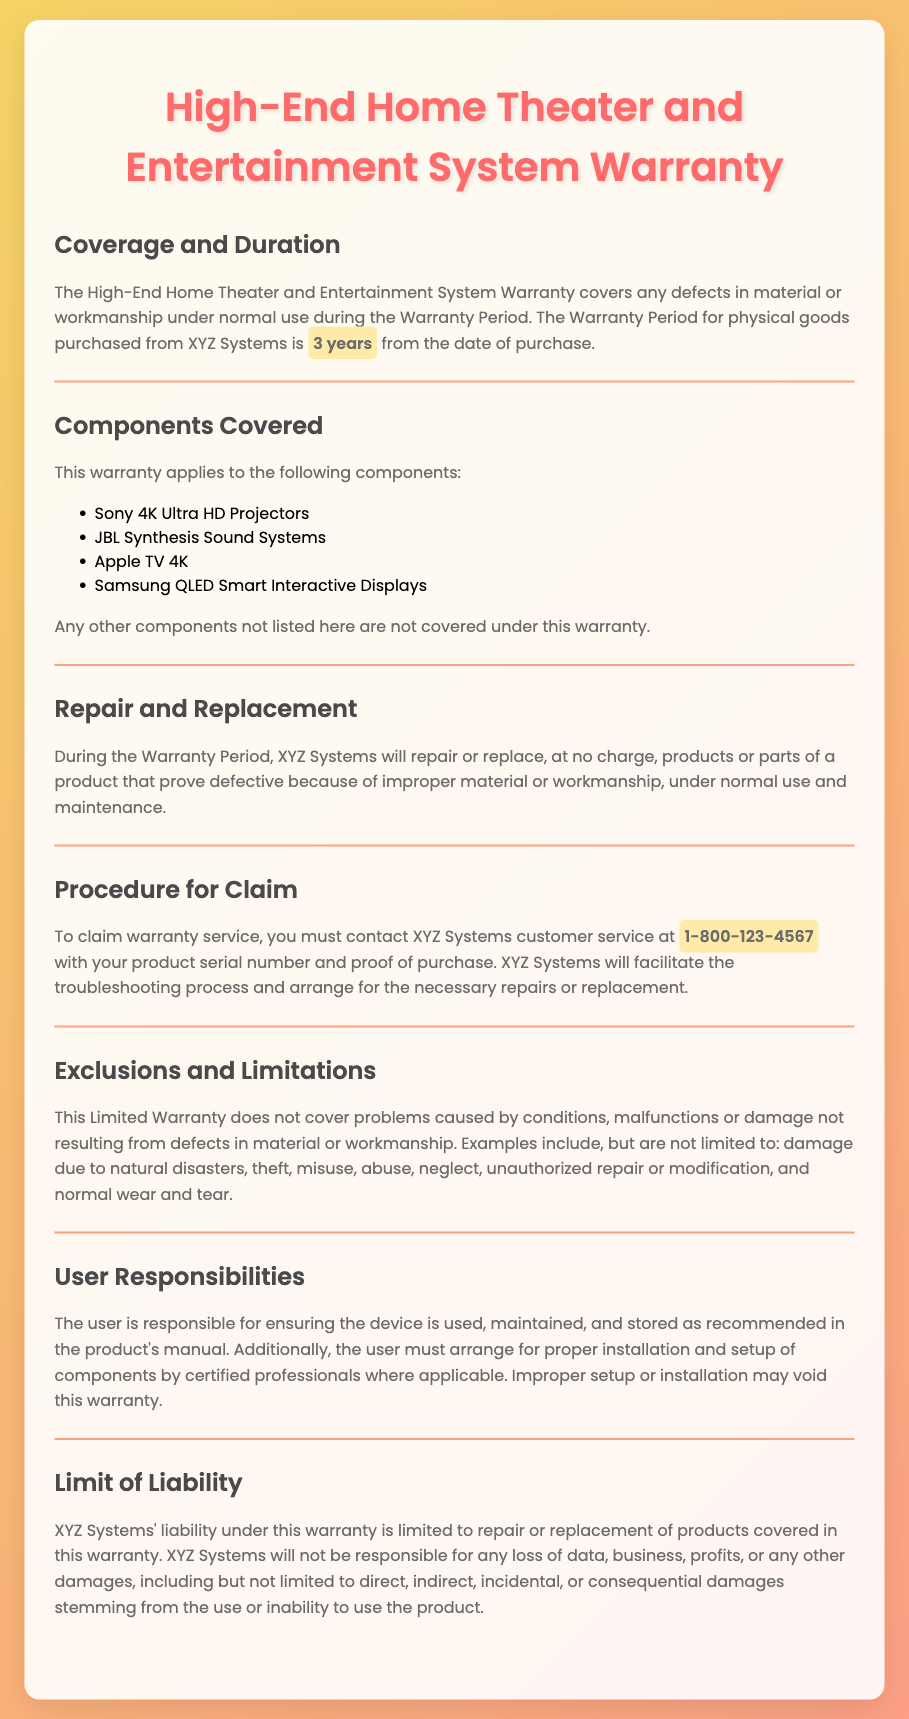What is the warranty period for the home theater system? The warranty period for the High-End Home Theater and Entertainment System is specified as 3 years from the date of purchase.
Answer: 3 years Which components are covered under the warranty? The warranty applies to specific components including Sony 4K Ultra HD Projectors, JBL Synthesis Sound Systems, Apple TV 4K, and Samsung QLED Smart Interactive Displays.
Answer: Sony 4K Ultra HD Projectors, JBL Synthesis Sound Systems, Apple TV 4K, Samsung QLED Smart Interactive Displays What must you provide to claim warranty service? To claim warranty service, you must provide your product serial number and proof of purchase to XYZ Systems customer service.
Answer: Product serial number and proof of purchase What conditions are excluded from the warranty? The warranty does not cover problems caused by conditions or damage not resulting from defects in material or workmanship, such as damage due to natural disasters or misuse.
Answer: Damage due to natural disasters, theft, misuse, abuse, neglect, unauthorized repair or modification, normal wear and tear What is the limit of liability for XYZ Systems? The limit of liability for XYZ Systems under the warranty is specified as being limited to repair or replacement of products covered in the warranty.
Answer: Repair or replacement of products covered in the warranty 